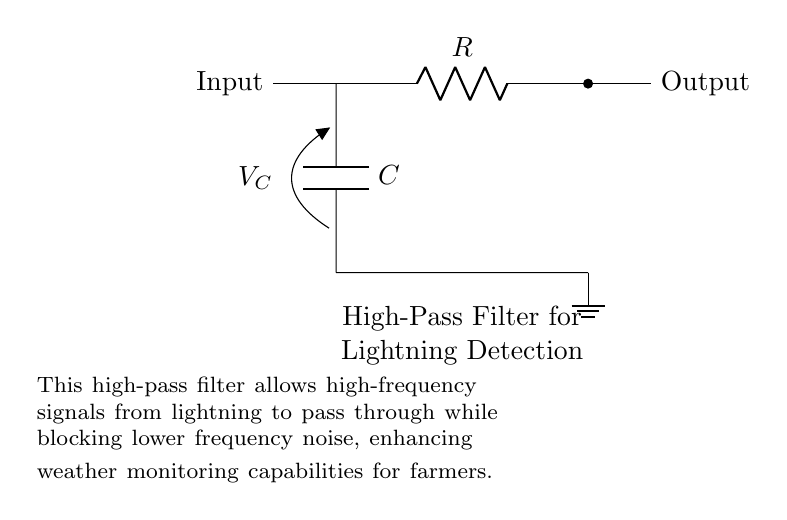What type of filter is this circuit? The circuit diagram represents a high-pass filter, which allows high-frequency signals to pass while attenuating low-frequency signals. This is indicated by the presence of a capacitor and resistor in configuration typical of high-pass filters.
Answer: High-pass filter What is the function of the capacitor in this circuit? The capacitor in a high-pass filter allows high-frequency signals to pass through while blocking low-frequency signals, charging and discharging based on the frequency of the incoming signal. This enables it to filter out unwanted noise while detecting lightning signals.
Answer: Block low frequencies What components are present in this circuit? The circuit contains a capacitor, a resistor, and a connection to ground. These components work together in the configuration typical for a high-pass filter designed for detecting lightning signals.
Answer: Capacitor and resistor What is the voltage across the capacitor? The diagram shows the voltage across the capacitor denoted as V_C, which indicates that it is variable depending on the input signal frequency and the filter characteristics. Since it's indicated and not specified with a value, it is primarily determined by operating conditions.
Answer: V_C What does the label "High-Pass Filter for Lightning Detection" indicate? This label describes the primary purpose of the circuit as designed to detect lightning by allowing high-frequency signals, which are indicative of lightning activity, to pass through while filtering out noise. It succinctly communicates the application's focus in weather monitoring by farmers.
Answer: Lightning detection What does the ground connection signify in this circuit? The ground connection serves as a reference point for the circuit, providing a common return path for current and ensuring stability in the circuit's operation, which is essential for reliable measurement and detection purposes.
Answer: Common reference point 